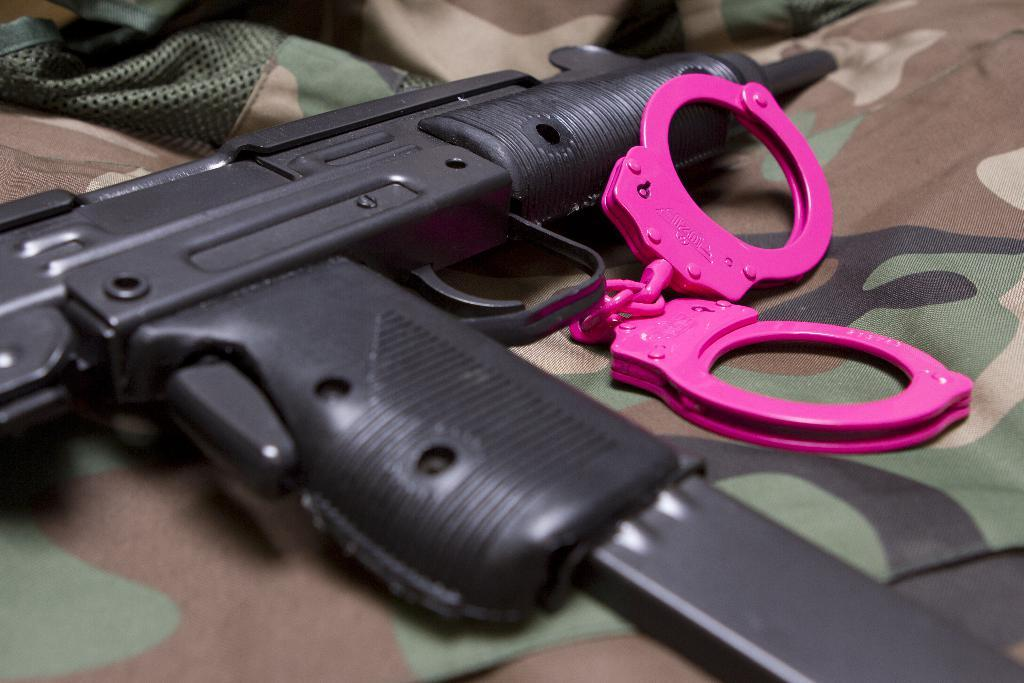What is the main object in the image? There is a gun in the image. What can be seen on the surface beneath the objects in the image? There is a camouflage cloth in the image. What other objects are present on the camouflage cloth? There are other objects on the camouflage cloth in the image, but their specific details are not mentioned in the provided facts. What type of sea creature can be seen swimming near the gun in the image? There is no sea creature present in the image; it features a gun and other objects on a camouflage cloth. What kind of nut is visible on the camouflage cloth in the image? There is no nut present in the image; it only features a gun and other objects on a camouflage cloth. 